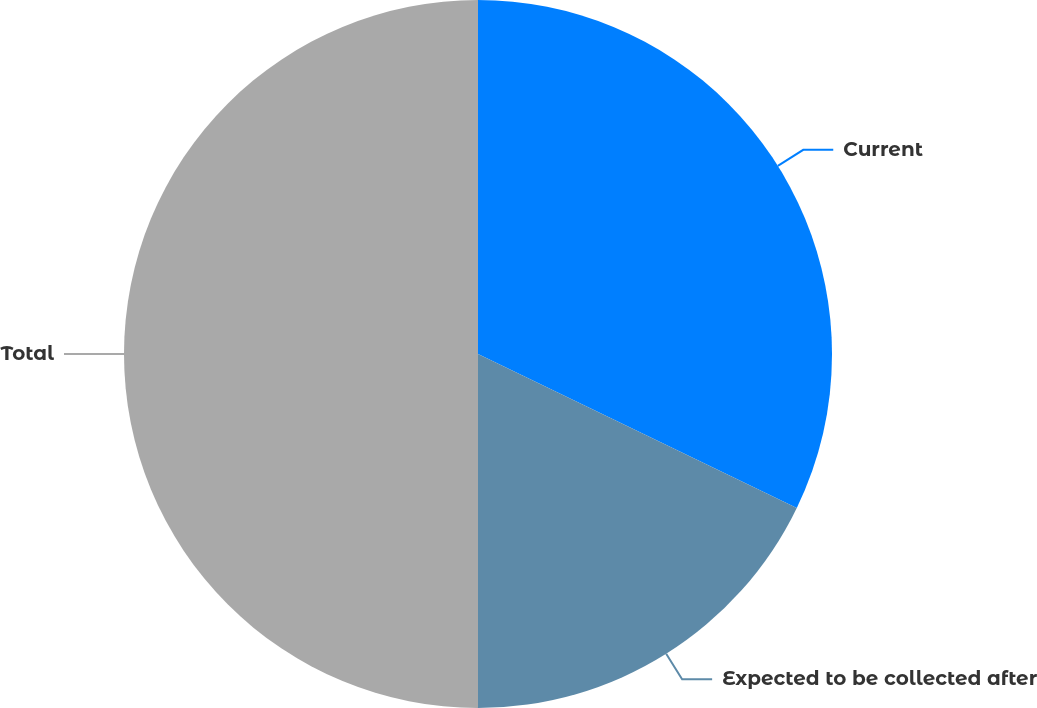<chart> <loc_0><loc_0><loc_500><loc_500><pie_chart><fcel>Current<fcel>Expected to be collected after<fcel>Total<nl><fcel>32.16%<fcel>17.84%<fcel>50.0%<nl></chart> 